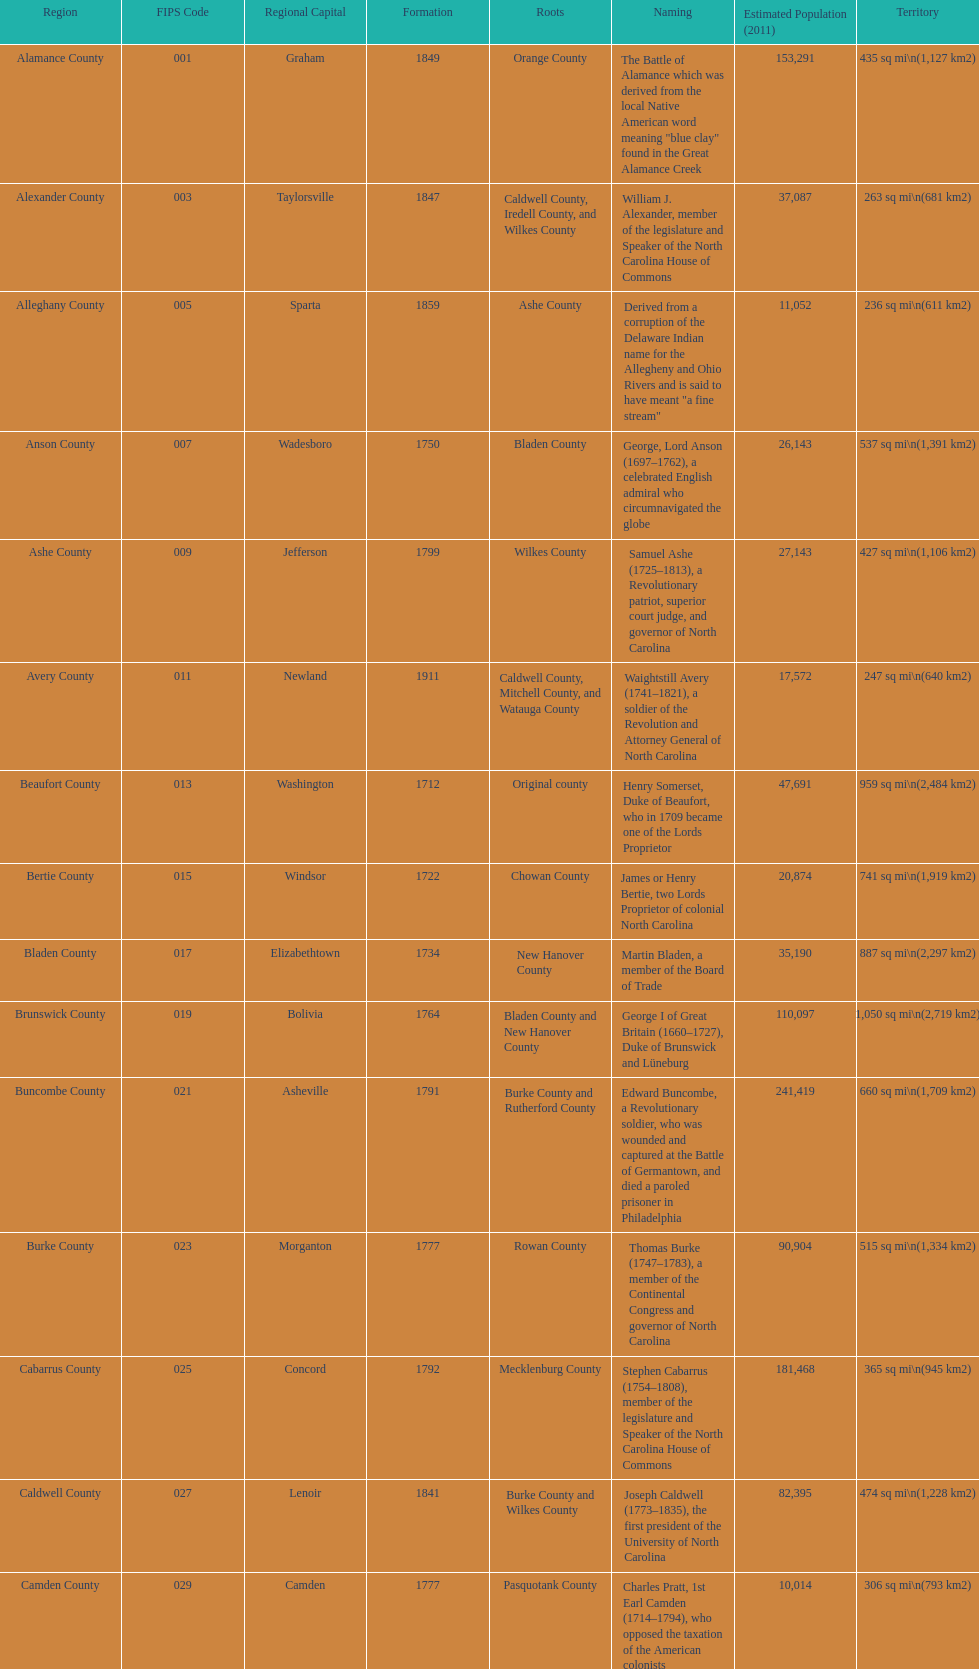Excluding mecklenburg, which county has the highest population? Wake County. 